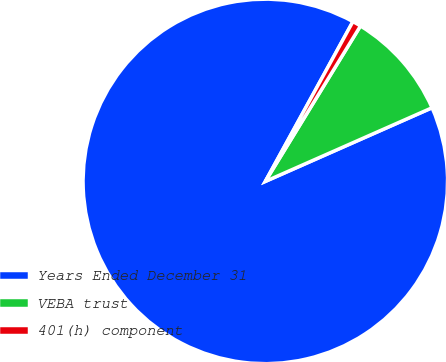Convert chart. <chart><loc_0><loc_0><loc_500><loc_500><pie_chart><fcel>Years Ended December 31<fcel>VEBA trust<fcel>401(h) component<nl><fcel>89.6%<fcel>9.64%<fcel>0.76%<nl></chart> 